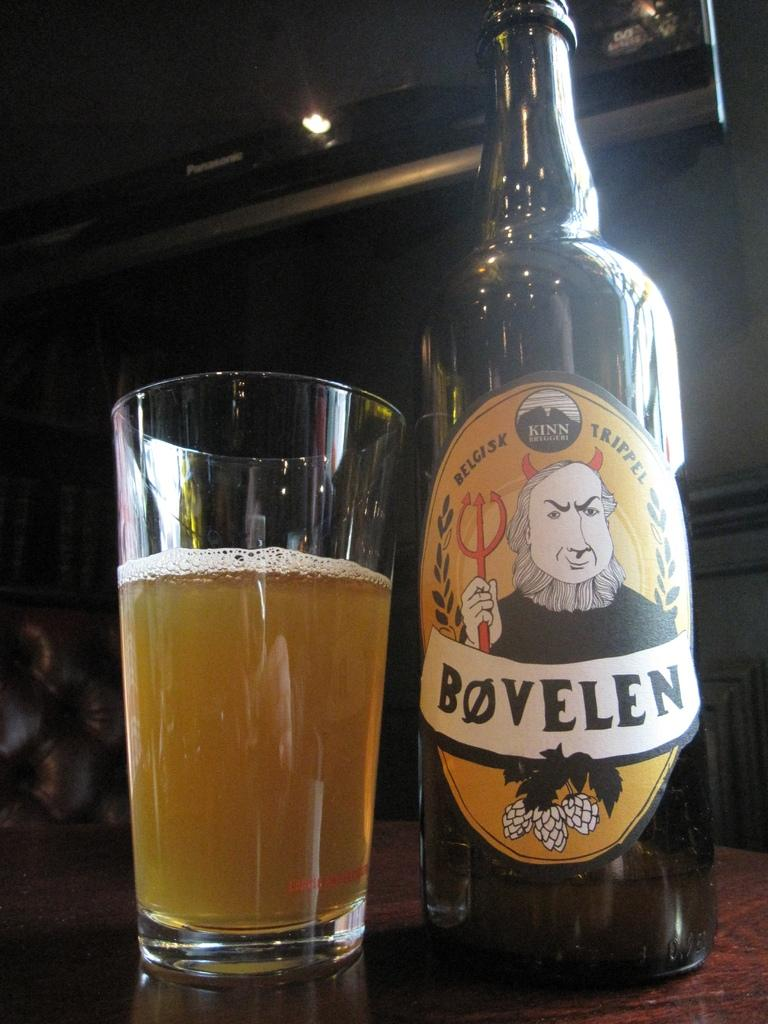<image>
Describe the image concisely. A glass of beer sits to the left of a bottle of Bøvelen. 